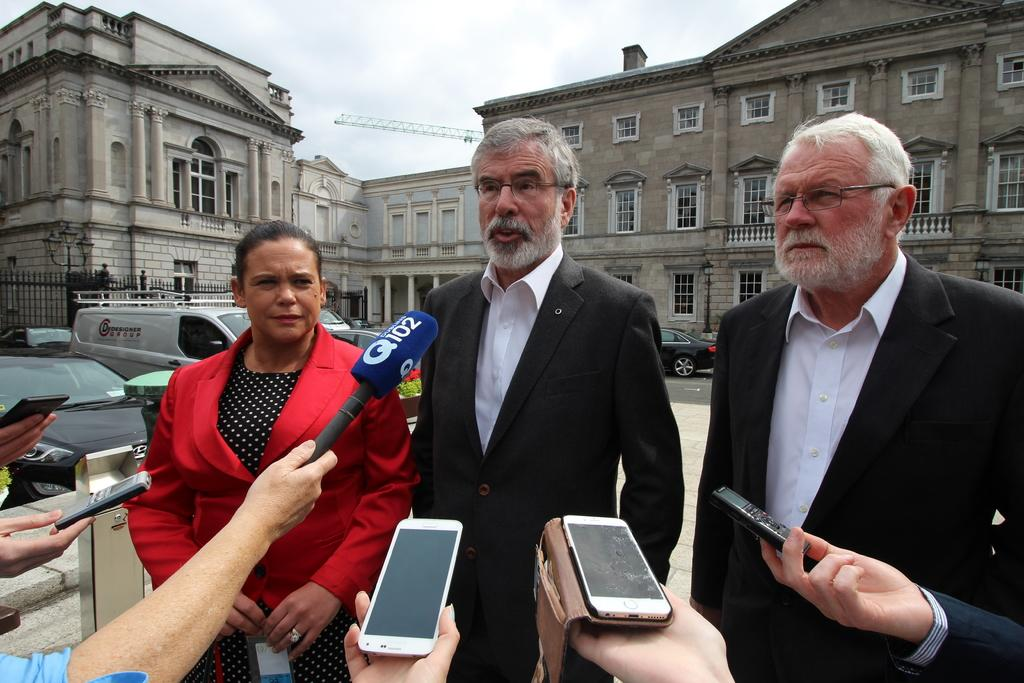<image>
Describe the image concisely. A woman and two men being interviewed by someone with a Q102 microphone. 